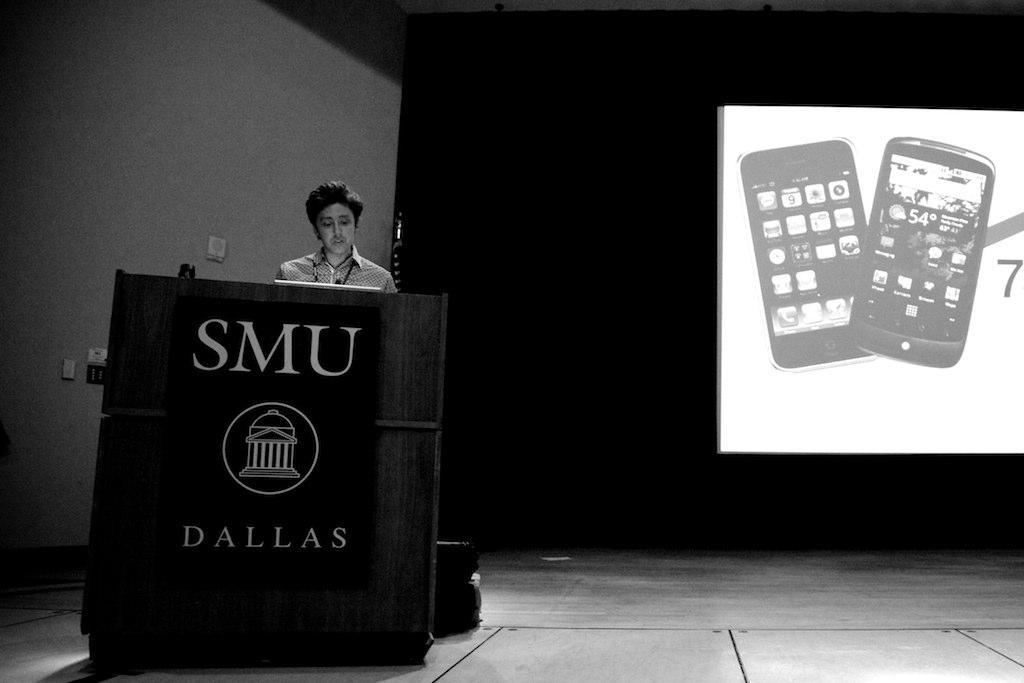What is the main subject of the image? There is a person standing in the image. Where is the person positioned in relation to the table? The person is standing behind the table. What can be seen on the wall in the image? There is a screen on the wall in the image. What is displayed on the screen? Two mobile devices are visible on the screen. What type of stocking is the person wearing in the image? There is no information about the person's clothing, including stockings, in the image. 